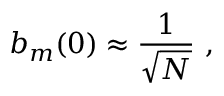Convert formula to latex. <formula><loc_0><loc_0><loc_500><loc_500>b _ { m } ( 0 ) \approx { \frac { 1 } { \sqrt { N } } } \ ,</formula> 